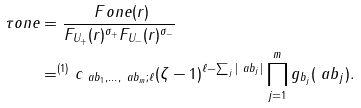<formula> <loc_0><loc_0><loc_500><loc_500>\tau o n e & = \frac { \ F o n e ( r ) } { F _ { U _ { + } } ( r ) ^ { \sigma _ { + } } F _ { U _ { - } } ( r ) ^ { \sigma _ { - } } } \\ & = ^ { ( 1 ) } c _ { \ a b _ { 1 } , \dots , \ a b _ { m } ; \ell } ( \zeta - 1 ) ^ { \ell - \sum _ { j } | \ a b _ { j } | } \prod _ { j = 1 } ^ { m } g _ { b _ { j } } ( \ a b _ { j } ) .</formula> 